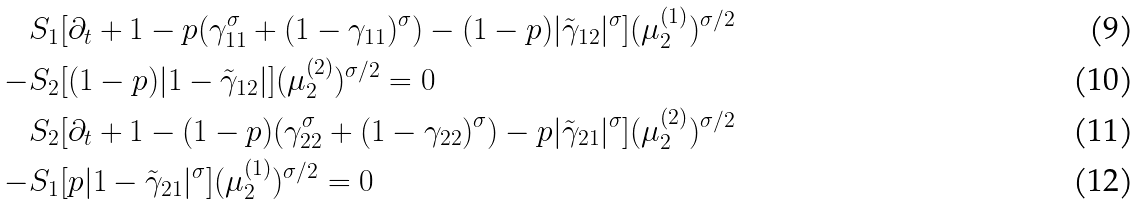<formula> <loc_0><loc_0><loc_500><loc_500>S _ { 1 } & [ \partial _ { t } + 1 - p ( \gamma _ { 1 1 } ^ { \sigma } + ( 1 - \gamma _ { 1 1 } ) ^ { \sigma } ) - ( 1 - p ) | \tilde { \gamma } _ { 1 2 } | ^ { \sigma } ] ( \mu ^ { ( 1 ) } _ { 2 } ) ^ { \sigma / 2 } \\ - S _ { 2 } & [ ( 1 - p ) | 1 - \tilde { \gamma } _ { 1 2 } | ] ( \mu ^ { ( 2 ) } _ { 2 } ) ^ { \sigma / 2 } = 0 \\ S _ { 2 } & [ \partial _ { t } + 1 - ( 1 - p ) ( \gamma _ { 2 2 } ^ { \sigma } + ( 1 - \gamma _ { 2 2 } ) ^ { \sigma } ) - p | \tilde { \gamma } _ { 2 1 } | ^ { \sigma } ] ( \mu ^ { ( 2 ) } _ { 2 } ) ^ { \sigma / 2 } \\ - S _ { 1 } & [ p | 1 - \tilde { \gamma } _ { 2 1 } | ^ { \sigma } ] ( \mu ^ { ( 1 ) } _ { 2 } ) ^ { \sigma / 2 } = 0</formula> 